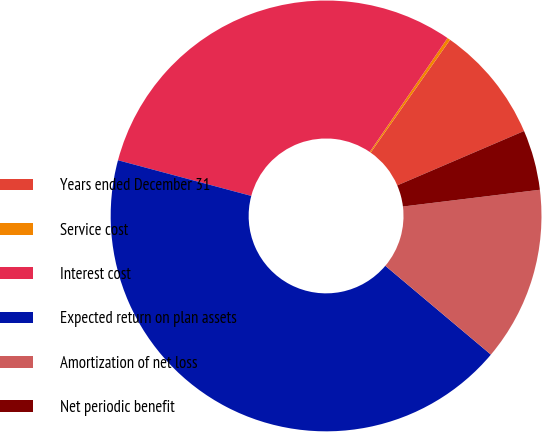<chart> <loc_0><loc_0><loc_500><loc_500><pie_chart><fcel>Years ended December 31<fcel>Service cost<fcel>Interest cost<fcel>Expected return on plan assets<fcel>Amortization of net loss<fcel>Net periodic benefit<nl><fcel>8.79%<fcel>0.23%<fcel>30.37%<fcel>43.03%<fcel>13.07%<fcel>4.51%<nl></chart> 